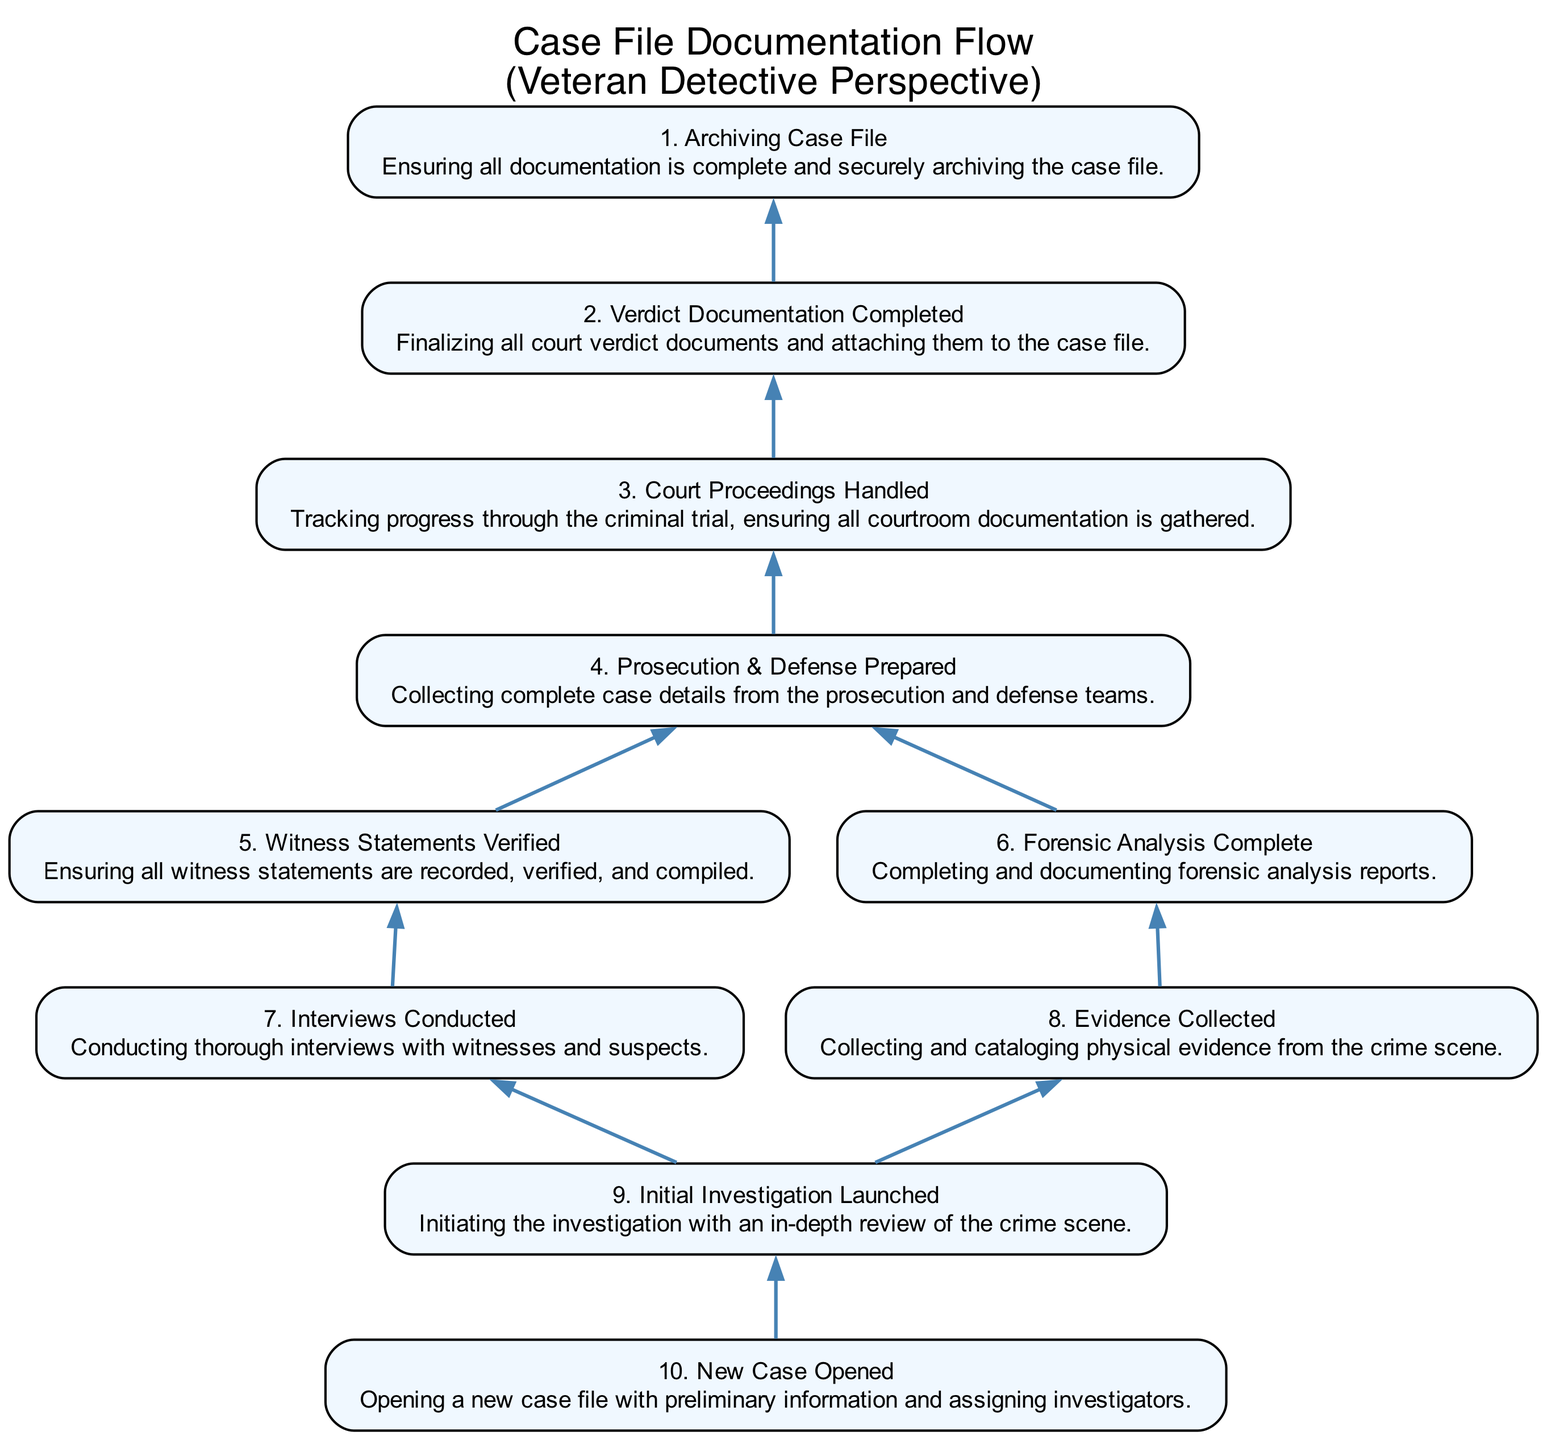What is the first step in the case file documentation process? The first step, as indicated in the diagram, is "10. New Case Opened." It is the beginning of the documentation process, setting the stage for further actions.
Answer: New Case Opened How many steps are there in the diagram? By counting all the nodes in the diagram, we find that there are a total of 10 steps from opening the case file to archiving it.
Answer: 10 What documents are finalized after the court proceedings? The documents specified in the flowchart are "2. Verdict Documentation Completed," which include all necessary court verdict documents attached to the case file.
Answer: Verdict Documentation Completed What must be completed before "Court Proceedings Handled"? The node "4. Prosecution & Defense Prepared" must be completed prior to moving on to "3. Court Proceedings Handled." This step is crucial for the tracking of courtroom documentation.
Answer: Prosecution & Defense Prepared Which processes include the verification of witness statements? The process of verifying witness statements is encompassed in "5. Witness Statements Verified." This step specifically addresses the accuracy and compilation of witness accounts after interviews.
Answer: Witness Statements Verified What are the two dependencies for the process "Prosecution & Defense Prepared"? The dependencies for "4. Prosecution & Defense Prepared" are "5. Witness Statements Verified" and "6. Forensic Analysis Complete," which are necessary to gather complete case details.
Answer: Witness Statements Verified, Forensic Analysis Complete In what stage does the evidence collection occur? Evidence collection occurs in the step called "8. Evidence Collected," which happens after the initial investigation has been launched. This is crucial for building a solid case.
Answer: Evidence Collected What is the final action taken in the case documentation process? The last action, as outlined in the flowchart, is "1. Archiving Case File," which involves ensuring that all documentation is complete before securely archiving the case.
Answer: Archiving Case File What must happen first before collecting evidence or conducting interviews? The very first step that needs to occur before any evidence can be collected or interviews can be conducted is "9. Initial Investigation Launched." This step initiates all subsequent actions.
Answer: Initial Investigation Launched What reports are completed as part of forensic analysis? The reports created within the forensic analysis process are summarized in "6. Forensic Analysis Complete," which entails the documentation of all forensic analysis findings.
Answer: Forensic Analysis Complete 